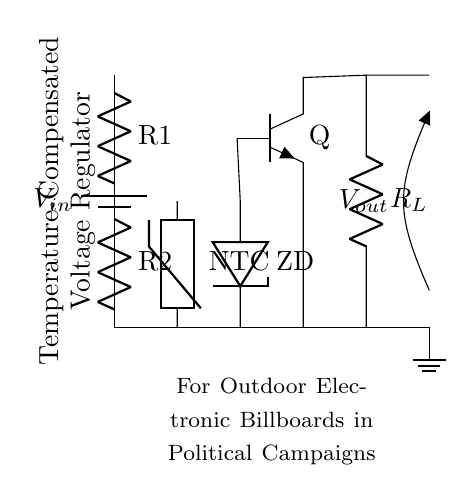What is the input voltage of this circuit? The input voltage is labeled as V_in, which is indicated in the circuit diagram connected to the battery symbol.
Answer: V_in What type of resistor is R1? R1 is a resistor in the circuit; however, there's no specific type indicated. It is just labeled as a resistor without further classification.
Answer: Resistor What component provides temperature compensation? The temperature compensation in the circuit is provided by the NTC thermistor, which is designed to change resistance with temperature variations.
Answer: NTC thermistor How many total resistors are in this circuit? The circuit diagram shows two resistors connected in series: R1 and R2. There is also an unspecified resistor labeled R_L which is the load resistor.
Answer: Two What is the role of the Zener diode? The Zener diode in the circuit is used for voltage regulation; it allows current to flow in the reverse direction when a specific voltage (Zener voltage) is reached, thus maintaining a stable output voltage.
Answer: Voltage regulation What type of transistor is used in this circuit? The transistor used is an NPN type, as indicated by the symbol and the label Q; this type allows current to flow from collector to emitter when a current is applied to the base.
Answer: NPN transistor What is the intended application of this voltage regulator? The circuit is specifically designed for outdoor electronic billboards used in political campaigns, as noted in the descriptive label within the diagram.
Answer: Outdoor electronic billboards 